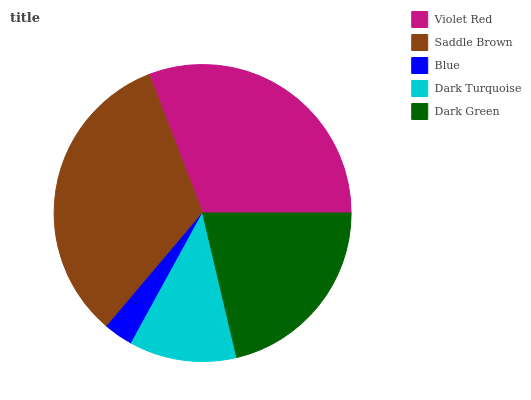Is Blue the minimum?
Answer yes or no. Yes. Is Saddle Brown the maximum?
Answer yes or no. Yes. Is Saddle Brown the minimum?
Answer yes or no. No. Is Blue the maximum?
Answer yes or no. No. Is Saddle Brown greater than Blue?
Answer yes or no. Yes. Is Blue less than Saddle Brown?
Answer yes or no. Yes. Is Blue greater than Saddle Brown?
Answer yes or no. No. Is Saddle Brown less than Blue?
Answer yes or no. No. Is Dark Green the high median?
Answer yes or no. Yes. Is Dark Green the low median?
Answer yes or no. Yes. Is Violet Red the high median?
Answer yes or no. No. Is Blue the low median?
Answer yes or no. No. 